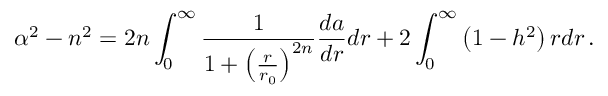<formula> <loc_0><loc_0><loc_500><loc_500>\alpha ^ { 2 } - n ^ { 2 } = 2 n \int _ { 0 } ^ { \infty } { \frac { 1 } { 1 + \left ( { \frac { r } { r _ { 0 } } } \right ) ^ { 2 n } } } { \frac { d a } { d r } } d r + 2 \int _ { 0 } ^ { \infty } \left ( 1 - h ^ { 2 } \right ) r d r \, .</formula> 